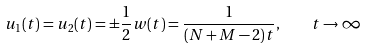<formula> <loc_0><loc_0><loc_500><loc_500>u _ { 1 } ( t ) = u _ { 2 } ( t ) = \pm \frac { 1 } { 2 } w ( t ) = \frac { 1 } { ( N + M - 2 ) t } , \quad t \rightarrow \infty</formula> 